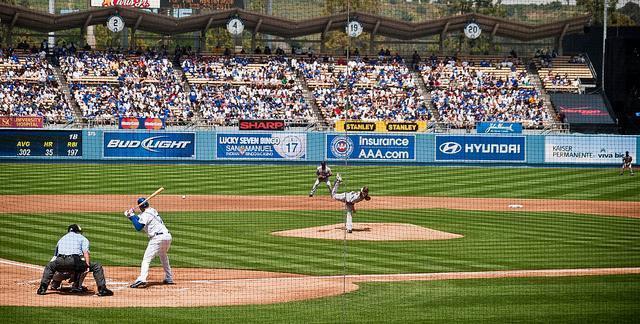How many people are visible?
Give a very brief answer. 2. How many dogs are still around the pool?
Give a very brief answer. 0. 